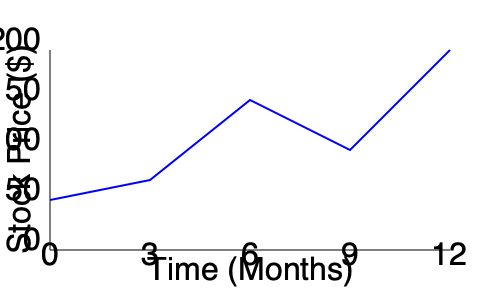Analyzing the stock price trend over the past year, during which 3-month period did the company experience the most significant value increase, potentially indicating a successful corporate espionage operation? To determine the 3-month period with the most significant value increase:

1. Divide the graph into 3-month intervals: 0-3, 3-6, 6-9, 9-12 months.
2. Calculate the price change for each interval:
   a. 0-3 months: Small decrease
   b. 3-6 months: Large increase
   c. 6-9 months: Moderate increase
   d. 9-12 months: Large increase

3. Compare the increases:
   - The largest increase occurs between months 3-6.
   - This period shows the steepest upward slope.

4. From a venture capitalist's perspective funding industrial espionage:
   - A sudden, significant price increase could indicate successful acquisition of valuable trade secrets.
   - The 3-6 month period aligns with the time it might take to implement stolen information and see market results.

Therefore, the 3-6 month period shows the most significant value increase, potentially indicating a successful corporate espionage operation.
Answer: 3-6 months 